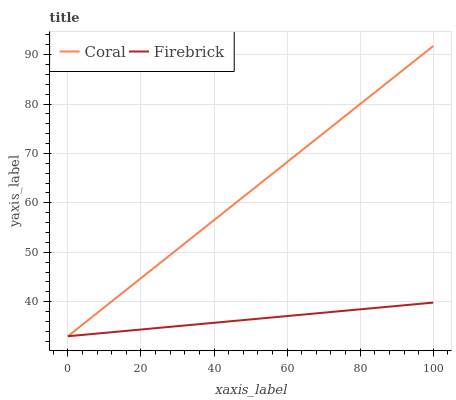Does Firebrick have the minimum area under the curve?
Answer yes or no. Yes. Does Coral have the maximum area under the curve?
Answer yes or no. Yes. Does Firebrick have the maximum area under the curve?
Answer yes or no. No. Is Firebrick the smoothest?
Answer yes or no. Yes. Is Coral the roughest?
Answer yes or no. Yes. Is Firebrick the roughest?
Answer yes or no. No. Does Coral have the highest value?
Answer yes or no. Yes. Does Firebrick have the highest value?
Answer yes or no. No. Does Firebrick intersect Coral?
Answer yes or no. Yes. Is Firebrick less than Coral?
Answer yes or no. No. Is Firebrick greater than Coral?
Answer yes or no. No. 